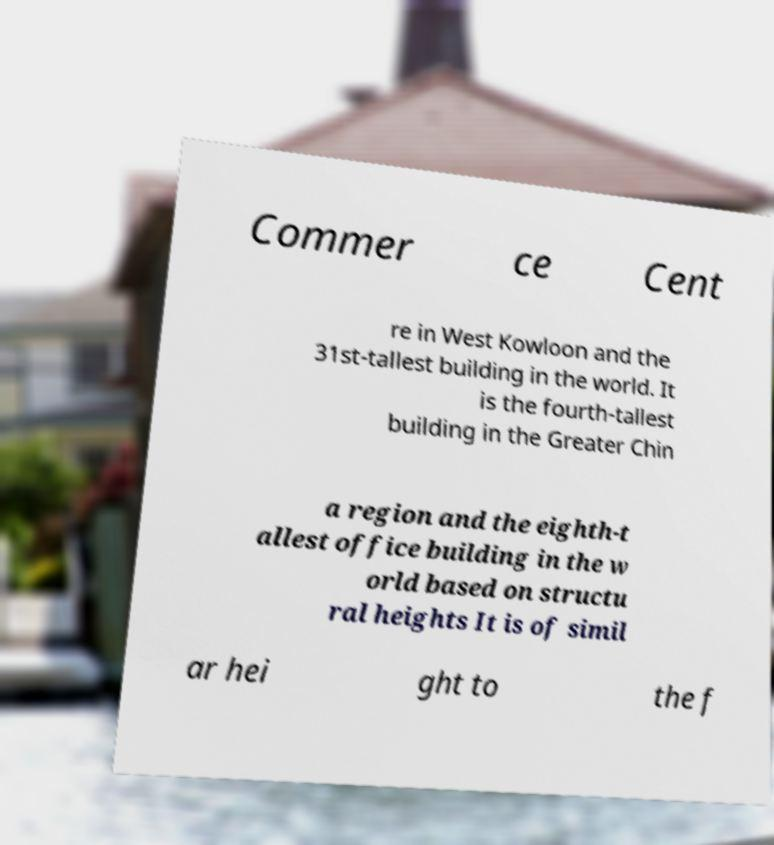Can you accurately transcribe the text from the provided image for me? Commer ce Cent re in West Kowloon and the 31st-tallest building in the world. It is the fourth-tallest building in the Greater Chin a region and the eighth-t allest office building in the w orld based on structu ral heights It is of simil ar hei ght to the f 